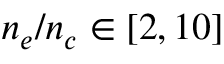<formula> <loc_0><loc_0><loc_500><loc_500>n _ { e } / n _ { c } \in [ 2 , 1 0 ]</formula> 